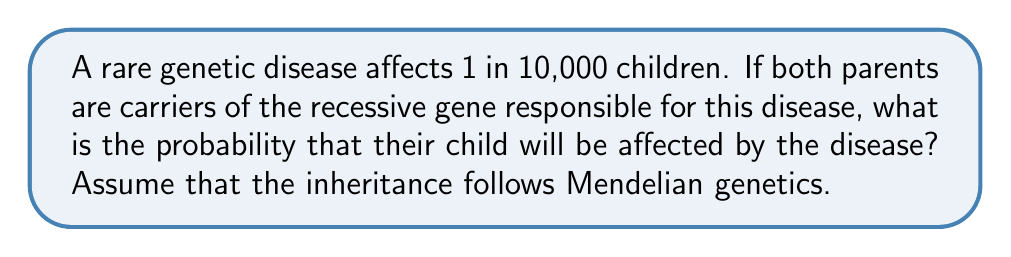Can you solve this math problem? To solve this problem, we need to understand the basics of Mendelian inheritance for recessive genetic disorders:

1) Let's denote the normal allele as "A" and the recessive disease-causing allele as "a".

2) For a child to be affected, they must inherit the recessive allele from both parents (aa).

3) If both parents are carriers, their genotype is "Aa".

4) The possible gametes from each parent are:
   - 50% chance of "A"
   - 50% chance of "a"

5) We can represent the possible offspring genotypes using a Punnett square:

   $$
   \begin{array}{c|c|c}
    & A (0.5) & a (0.5) \\
   \hline
   A (0.5) & AA (0.25) & Aa (0.25) \\
   \hline
   a (0.5) & Aa (0.25) & aa (0.25) \\
   \end{array}
   $$

6) From the Punnett square, we can see that the probability of an affected child (aa) is 0.25 or 25%.

7) To verify this mathematically:
   $P(aa) = P(a \text{ from father}) \times P(a \text{ from mother}) = 0.5 \times 0.5 = 0.25$

Therefore, the probability that the child will be affected by the disease is 0.25 or 25%.
Answer: The probability that the child will be affected by the rare genetic disease is 0.25 or 25%. 